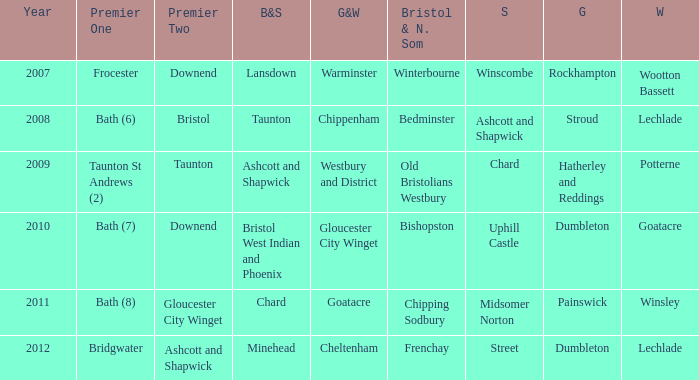Who many times is gloucestershire is painswick? 1.0. 